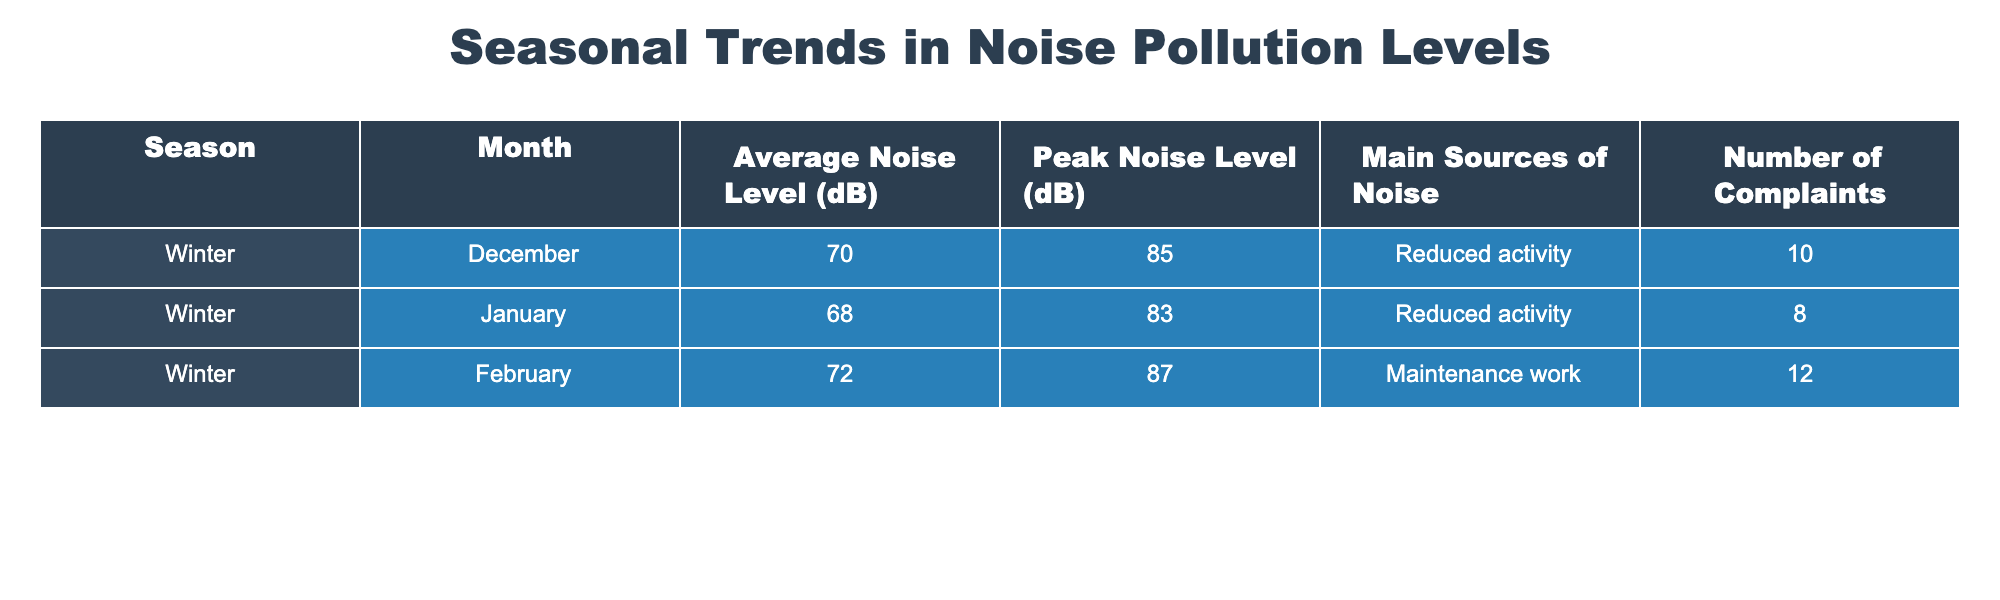What is the average noise level in February? The average noise level for February is provided in the table as 72 dB.
Answer: 72 dB Which month recorded the highest peak noise level? By looking at the peak noise levels in the table, February has the highest peak noise level at 87 dB.
Answer: February How many complaints were recorded in December? The table shows that the number of complaints recorded in December is 10.
Answer: 10 What is the difference between the average noise level in December and January? The average noise level in December is 70 dB, and in January is 68 dB. The difference is 70 - 68 = 2 dB.
Answer: 2 dB Which month has the lowest number of complaints, and how many were there? December has 10, January has 8, and February has 12. January has the lowest complaints with 8.
Answer: January, 8 complaints What is the total number of complaints across all three months? Adding up the complaints: December (10) + January (8) + February (12) = 30 total complaints.
Answer: 30 complaints Are there any months with a peak noise level over 85 dB? Looking at the peak noise levels, both February (87 dB) and January (83 dB) are below or above 85 dB; February exceeds it.
Answer: Yes, February Which month had maintenance work as the main source of noise? According to the table, February is listed as the month with maintenance work as the main source of noise.
Answer: February What is the average noise level for the winter months? We calculate the average by summing the average noise levels: (70 + 68 + 72) / 3 = 210 / 3 = 70 dB.
Answer: 70 dB Was the number of complaints in January higher than in December? The number of complaints in January (8) is less than in December (10). Therefore, the statement is false.
Answer: No 